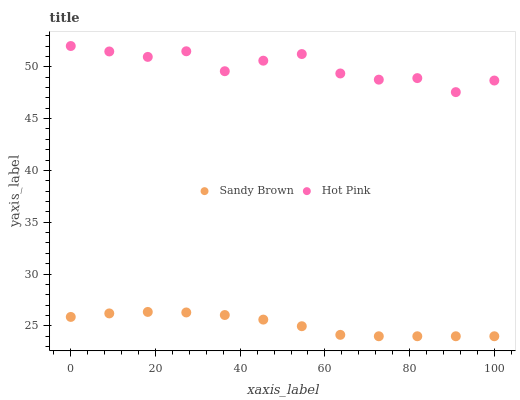Does Sandy Brown have the minimum area under the curve?
Answer yes or no. Yes. Does Hot Pink have the maximum area under the curve?
Answer yes or no. Yes. Does Sandy Brown have the maximum area under the curve?
Answer yes or no. No. Is Sandy Brown the smoothest?
Answer yes or no. Yes. Is Hot Pink the roughest?
Answer yes or no. Yes. Is Sandy Brown the roughest?
Answer yes or no. No. Does Sandy Brown have the lowest value?
Answer yes or no. Yes. Does Hot Pink have the highest value?
Answer yes or no. Yes. Does Sandy Brown have the highest value?
Answer yes or no. No. Is Sandy Brown less than Hot Pink?
Answer yes or no. Yes. Is Hot Pink greater than Sandy Brown?
Answer yes or no. Yes. Does Sandy Brown intersect Hot Pink?
Answer yes or no. No. 